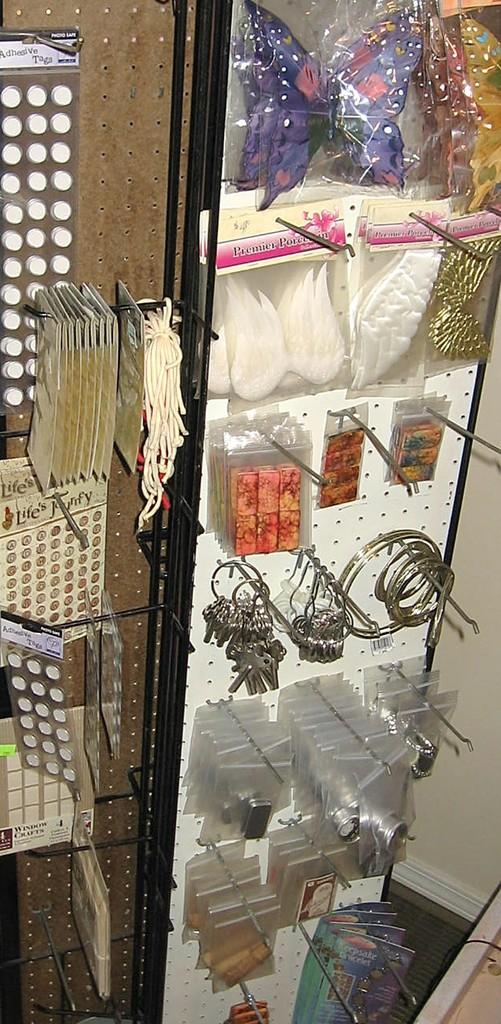What objects can be seen in the image that might be used for unlocking doors? There are keys in the image that might be used for unlocking doors. What type of jewelry is visible in the image? There are rings in the image. What is hanging on the wall in the image? There are stickers and accessories hanging on the wall in the image. Can you tell me what type of food is being served in the image? There is no food present in the image; it features keys, rings, stickers, and accessories hanging on the wall. 